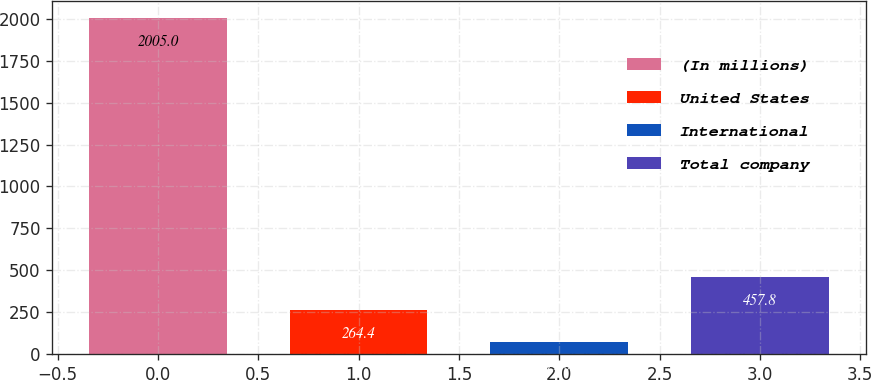Convert chart. <chart><loc_0><loc_0><loc_500><loc_500><bar_chart><fcel>(In millions)<fcel>United States<fcel>International<fcel>Total company<nl><fcel>2005<fcel>264.4<fcel>71<fcel>457.8<nl></chart> 